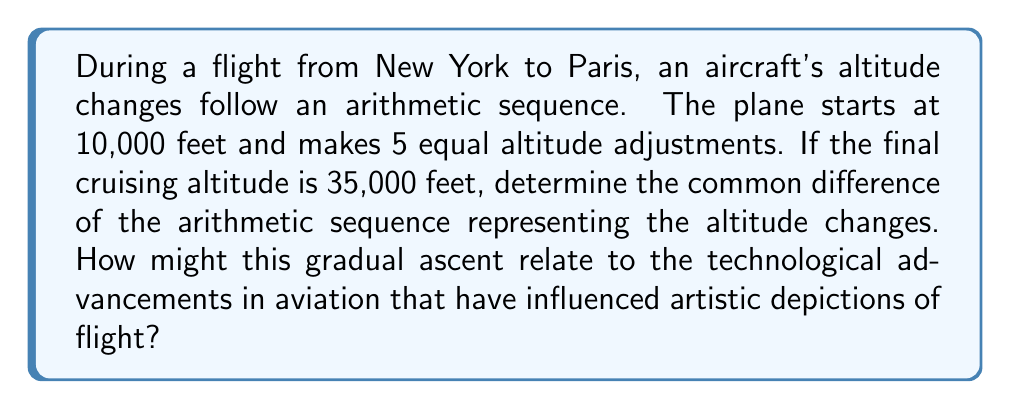Give your solution to this math problem. Let's approach this step-by-step:

1) In an arithmetic sequence, the difference between each term is constant. Let's call this common difference $d$.

2) We know:
   - Initial altitude: $a_1 = 10,000$ feet
   - Final altitude: $a_6 = 35,000$ feet (after 5 changes, so it's the 6th term)
   - Number of terms: $n = 6$

3) For an arithmetic sequence, the nth term is given by:
   $a_n = a_1 + (n-1)d$

4) Substituting our known values:
   $35,000 = 10,000 + (6-1)d$
   $35,000 = 10,000 + 5d$

5) Solving for $d$:
   $25,000 = 5d$
   $d = 25,000 \div 5 = 5,000$

6) Therefore, the common difference is 5,000 feet.

This gradual ascent reflects the technological advancements in aviation, allowing for smoother, more controlled climbs. Artists depicting flight might use this understanding to create more accurate or dynamic representations of aircraft in ascent, capturing the mathematical precision behind modern aviation.
Answer: $5,000$ feet 